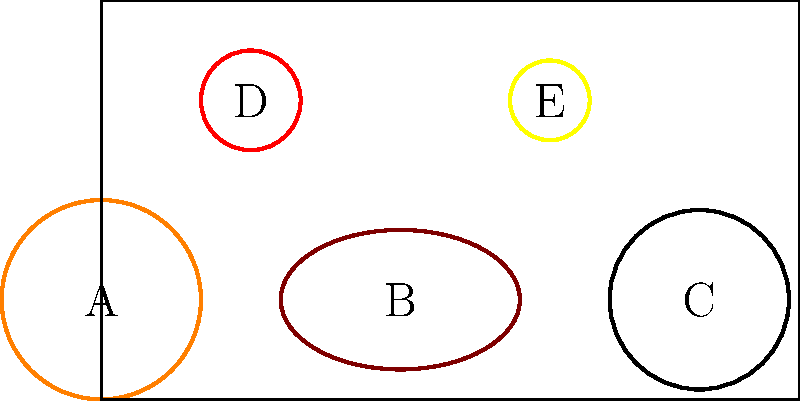As the basketball team captain, you're tasked with optimizing the storage space for various sports equipment. Given the arrangement of balls shown in the diagram, what is the most efficient order to remove the balls from the storage box to maximize space utilization? List the balls in the order they should be removed, using their corresponding letters. To optimize storage space, we should remove the balls in order from largest to smallest. This allows for better rearrangement of the remaining balls. Let's analyze the sizes:

1. Ball B (football) appears to be the largest due to its elongated shape.
2. Ball A (basketball) is the next largest circular ball.
3. Ball C (soccer ball) is slightly smaller than the basketball.
4. Ball D (baseball) is significantly smaller than the previous balls.
5. Ball E (tennis ball) is the smallest ball in the arrangement.

By removing the balls in this order, we create the most space each time, allowing for efficient rearrangement of the remaining balls. This strategy aligns with the basketball captain's focus on optimizing sports resources and space utilization.
Answer: B, A, C, D, E 